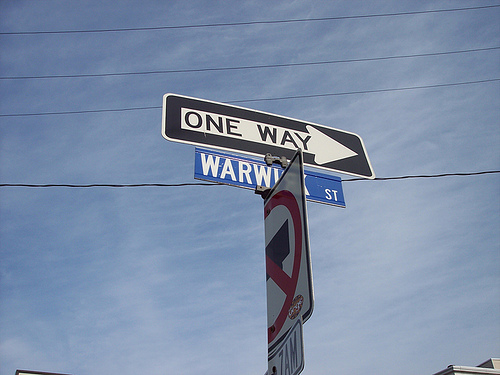<image>Where is the dead end? There is no dead end shown in the image. However, responses suggest it could be to the right or left. Where is the dead end? It is ambiguous where the dead end is. It can be seen both to the right and to the left. 